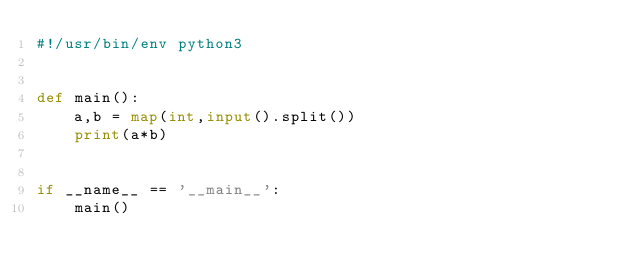Convert code to text. <code><loc_0><loc_0><loc_500><loc_500><_Python_>#!/usr/bin/env python3


def main():
    a,b = map(int,input().split())
    print(a*b)


if __name__ == '__main__':
    main()</code> 